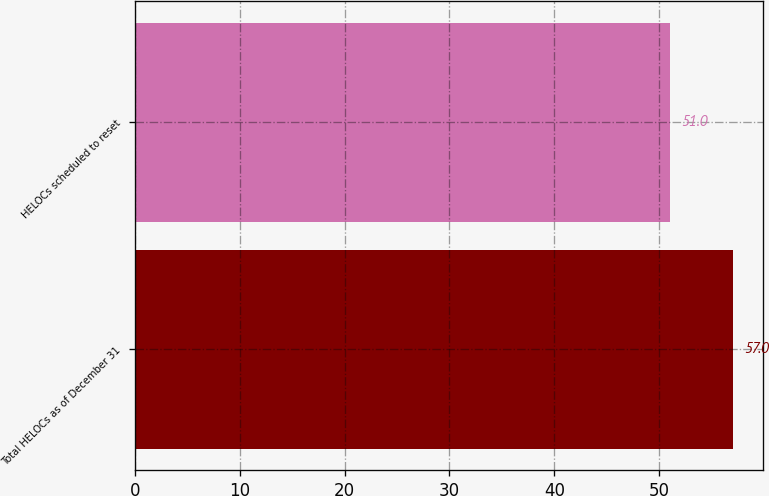Convert chart to OTSL. <chart><loc_0><loc_0><loc_500><loc_500><bar_chart><fcel>Total HELOCs as of December 31<fcel>HELOCs scheduled to reset<nl><fcel>57<fcel>51<nl></chart> 